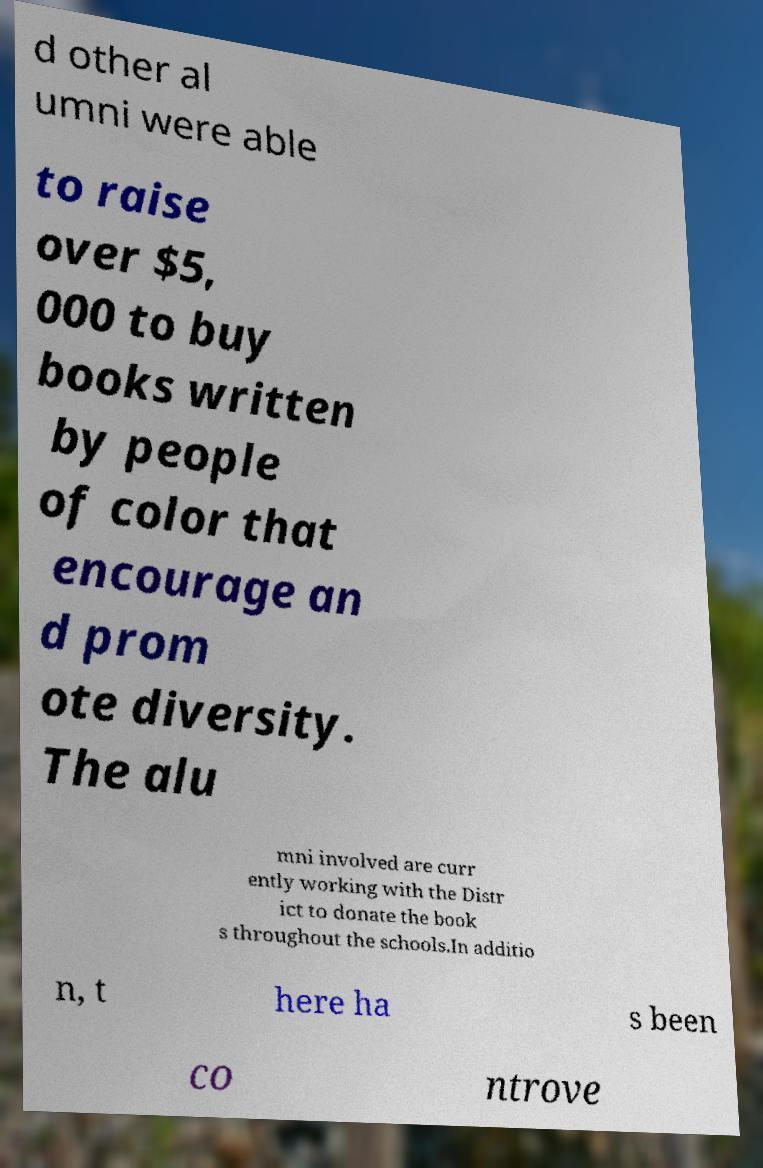What messages or text are displayed in this image? I need them in a readable, typed format. d other al umni were able to raise over $5, 000 to buy books written by people of color that encourage an d prom ote diversity. The alu mni involved are curr ently working with the Distr ict to donate the book s throughout the schools.In additio n, t here ha s been co ntrove 